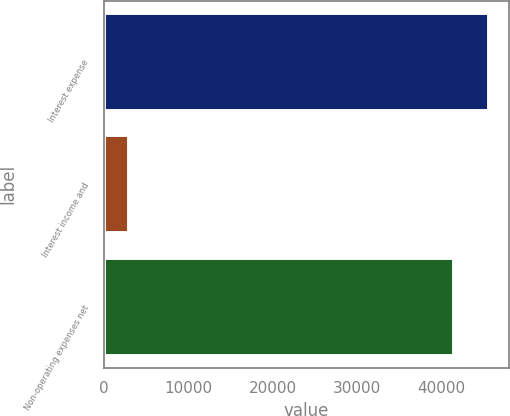<chart> <loc_0><loc_0><loc_500><loc_500><bar_chart><fcel>Interest expense<fcel>Interest income and<fcel>Non-operating expenses net<nl><fcel>45716<fcel>2960<fcel>41560<nl></chart> 